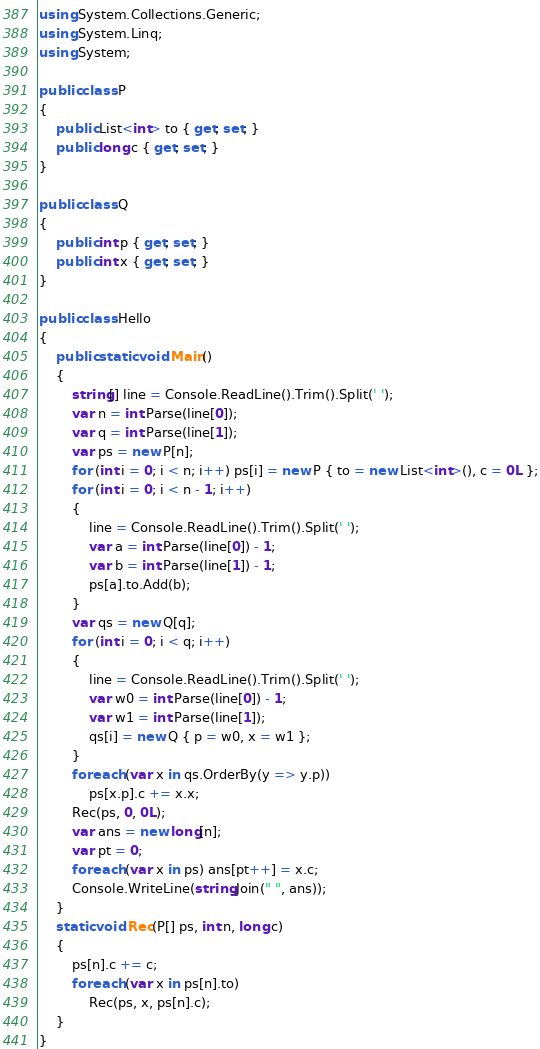<code> <loc_0><loc_0><loc_500><loc_500><_C#_>using System.Collections.Generic;
using System.Linq;
using System;

public class P
{
    public List<int> to { get; set; }
    public long c { get; set; }
}

public class Q
{
    public int p { get; set; }
    public int x { get; set; }
}

public class Hello
{
    public static void Main()
    {
        string[] line = Console.ReadLine().Trim().Split(' ');
        var n = int.Parse(line[0]);
        var q = int.Parse(line[1]);
        var ps = new P[n];
        for (int i = 0; i < n; i++) ps[i] = new P { to = new List<int>(), c = 0L };
        for (int i = 0; i < n - 1; i++)
        {
            line = Console.ReadLine().Trim().Split(' ');
            var a = int.Parse(line[0]) - 1;
            var b = int.Parse(line[1]) - 1;
            ps[a].to.Add(b);
        }
        var qs = new Q[q];
        for (int i = 0; i < q; i++)
        {
            line = Console.ReadLine().Trim().Split(' ');
            var w0 = int.Parse(line[0]) - 1;
            var w1 = int.Parse(line[1]);
            qs[i] = new Q { p = w0, x = w1 };
        }
        foreach (var x in qs.OrderBy(y => y.p))
            ps[x.p].c += x.x;
        Rec(ps, 0, 0L);
        var ans = new long[n];
        var pt = 0;
        foreach (var x in ps) ans[pt++] = x.c;
        Console.WriteLine(string.Join(" ", ans));
    }
    static void Rec(P[] ps, int n, long c)
    {
        ps[n].c += c;
        foreach (var x in ps[n].to)
            Rec(ps, x, ps[n].c);
    }
}
</code> 